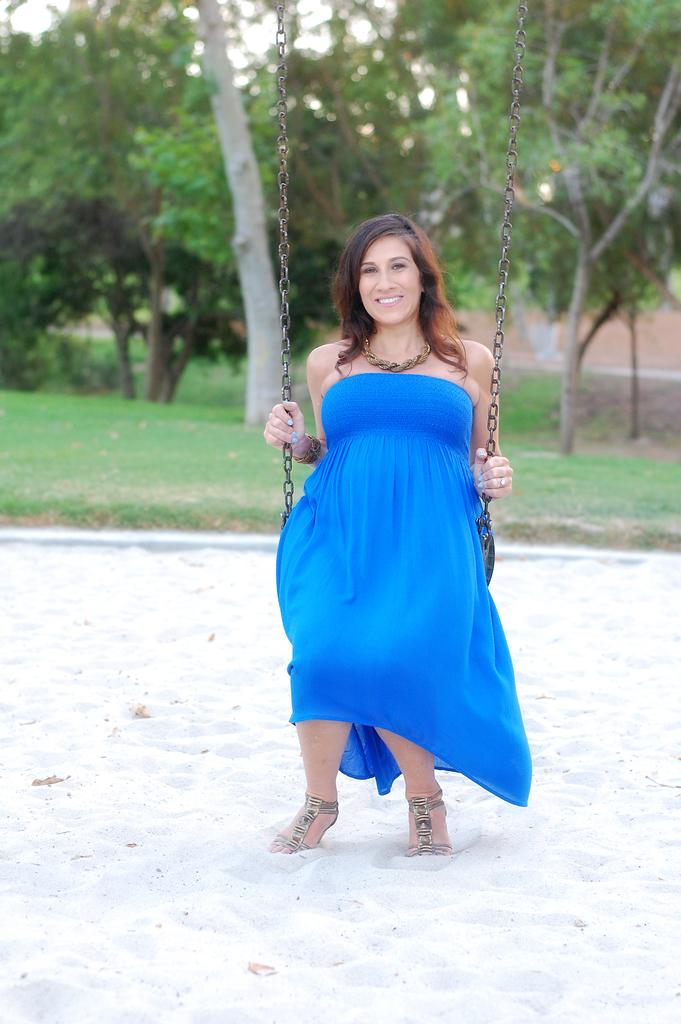Who is the main subject in the image? There is a woman in the image. What is the woman wearing? The woman is wearing a blue dress. What is the woman doing in the image? The woman is sitting on a seat. How is the seat supported? The seat is held with chains. What can be seen in the background of the image? There is a group of trees in the background of the image. What type of snakes can be seen slithering on the ground in the image? There are no snakes present in the image; it features a woman sitting on a seat held with chains, with a group of trees in the background. 